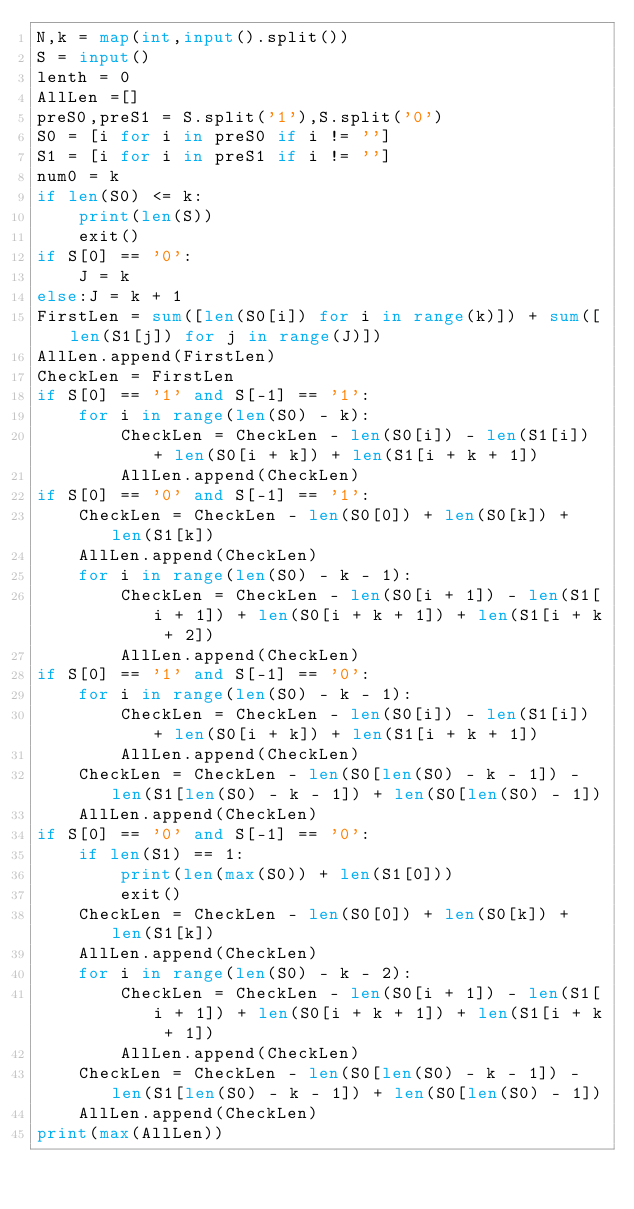<code> <loc_0><loc_0><loc_500><loc_500><_Python_>N,k = map(int,input().split())
S = input()
lenth = 0
AllLen =[]
preS0,preS1 = S.split('1'),S.split('0')
S0 = [i for i in preS0 if i != '']
S1 = [i for i in preS1 if i != '']
num0 = k
if len(S0) <= k:
	print(len(S))
	exit() 
if S[0] == '0':
	J = k
else:J = k + 1
FirstLen = sum([len(S0[i]) for i in range(k)]) + sum([len(S1[j]) for j in range(J)])
AllLen.append(FirstLen)
CheckLen = FirstLen
if S[0] == '1' and S[-1] == '1':
    for i in range(len(S0) - k):
	    CheckLen = CheckLen - len(S0[i]) - len(S1[i]) + len(S0[i + k]) + len(S1[i + k + 1])
	    AllLen.append(CheckLen)
if S[0] == '0' and S[-1] == '1':
	CheckLen = CheckLen - len(S0[0]) + len(S0[k]) + len(S1[k])
	AllLen.append(CheckLen)
	for i in range(len(S0) - k - 1):
		CheckLen = CheckLen - len(S0[i + 1]) - len(S1[i + 1]) + len(S0[i + k + 1]) + len(S1[i + k + 2])
		AllLen.append(CheckLen)
if S[0] == '1' and S[-1] == '0':
	for i in range(len(S0) - k - 1):
		CheckLen = CheckLen - len(S0[i]) - len(S1[i]) + len(S0[i + k]) + len(S1[i + k + 1])
		AllLen.append(CheckLen)
	CheckLen = CheckLen - len(S0[len(S0) - k - 1]) - len(S1[len(S0) - k - 1]) + len(S0[len(S0) - 1])
	AllLen.append(CheckLen)
if S[0] == '0' and S[-1] == '0':
	if len(S1) == 1:
		print(len(max(S0)) + len(S1[0]))
		exit()
	CheckLen = CheckLen - len(S0[0]) + len(S0[k]) + len(S1[k])
	AllLen.append(CheckLen)
	for i in range(len(S0) - k - 2):
		CheckLen = CheckLen - len(S0[i + 1]) - len(S1[i + 1]) + len(S0[i + k + 1]) + len(S1[i + k + 1])
		AllLen.append(CheckLen)
	CheckLen = CheckLen - len(S0[len(S0) - k - 1]) - len(S1[len(S0) - k - 1]) + len(S0[len(S0) - 1])
	AllLen.append(CheckLen)
print(max(AllLen))</code> 